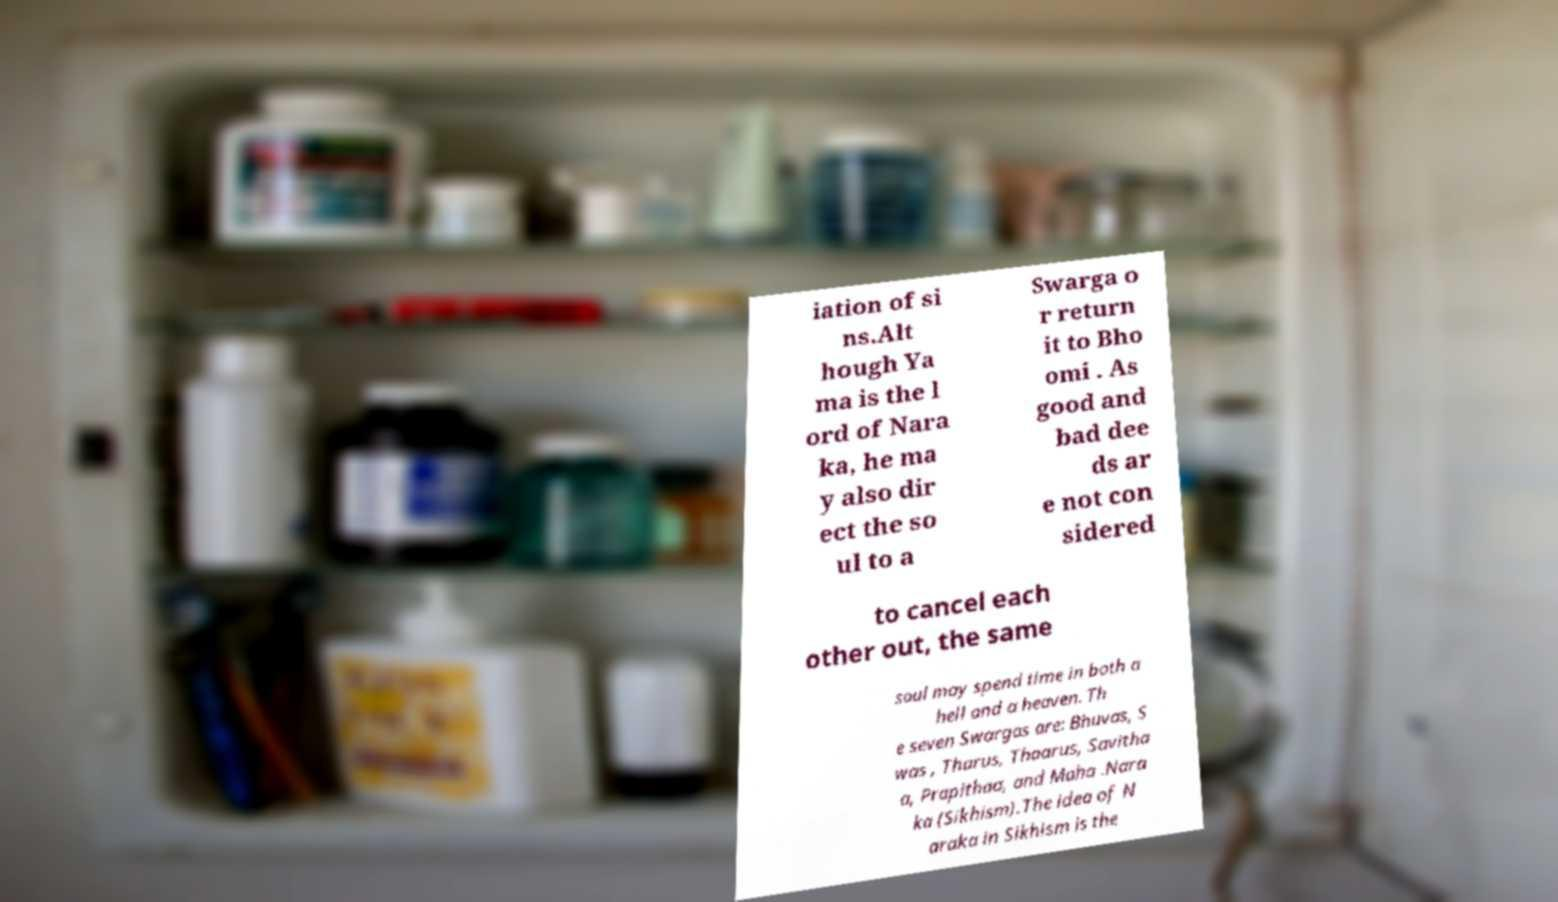Can you accurately transcribe the text from the provided image for me? iation of si ns.Alt hough Ya ma is the l ord of Nara ka, he ma y also dir ect the so ul to a Swarga o r return it to Bho omi . As good and bad dee ds ar e not con sidered to cancel each other out, the same soul may spend time in both a hell and a heaven. Th e seven Swargas are: Bhuvas, S was , Tharus, Thaarus, Savitha a, Prapithaa, and Maha .Nara ka (Sikhism).The idea of N araka in Sikhism is the 